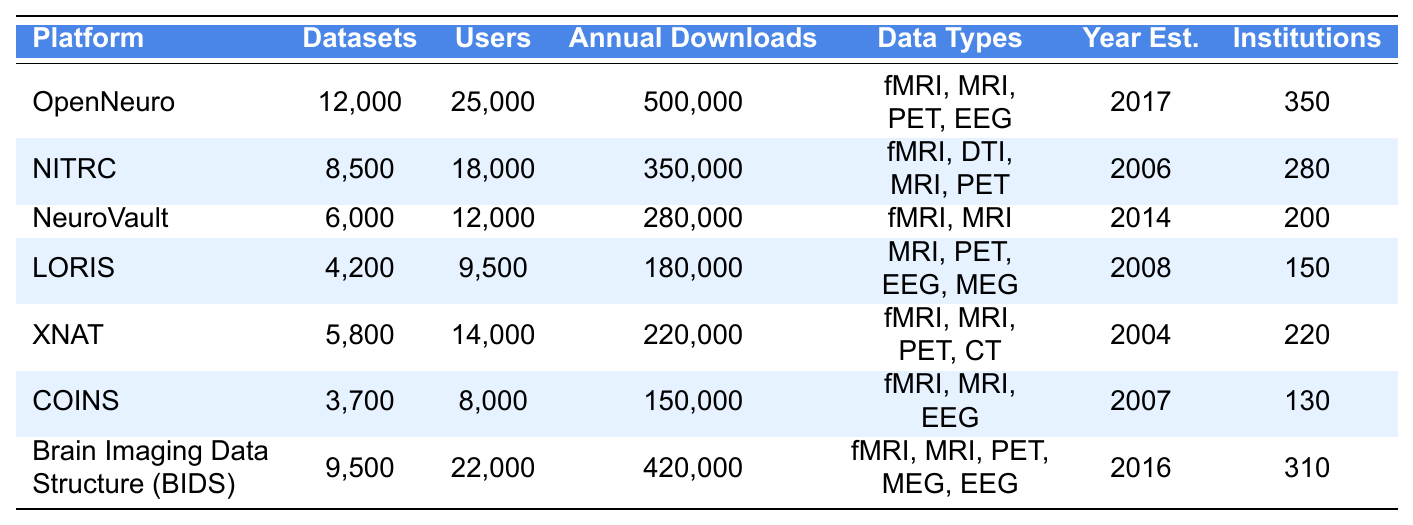What is the total number of datasets available across all platforms? To find the total number of datasets, we sum all the values in the datasets column: 12000 + 8500 + 6000 + 4200 + 5800 + 3700 + 9500 = 40800.
Answer: 40800 Which platform has the highest number of registered users? By inspecting the users column, OpenNeuro has the highest number of registered users with 25000.
Answer: OpenNeuro What percentage of institutions use the NITRC platform compared to OpenNeuro? To find the percentage, first determine the number of institutions using NITRC (280) and OpenNeuro (350). Then calculate: (280 / 350) * 100 = 80%.
Answer: 80% Is the statement "NITRC was established before Brain Imaging Data Structure (BIDS)" true? NITRC was established in 2006 and BIDS in 2016, so the statement is true as 2006 is earlier than 2016.
Answer: True Which platform has the lowest annual downloads, and what is that number? By comparing the annual downloads, COINS has the lowest with 150000 downloads.
Answer: COINS, 150000 If we look for the median number of datasets across these platforms, what do we find? Arranging the number of datasets (from least to most): 3700, 4200, 5800, 6000, 8500, 12000. The median of these six values, which is the average of the third and fourth values, is (5800 + 6000) / 2 = 5900.
Answer: 5900 What is the average number of registered users for all the platforms? To calculate the average, sum the registered users: 25000 + 18000 + 12000 + 9500 + 14000 + 8000 + 22000 = 108500, then divide by the number of platforms (7): 108500 / 7 = 15500.
Answer: 15500 Identify the platform that supports both EEG and fMRI data types. The platforms supporting both EEG and fMRI are OpenNeuro, LORIS, COINS, and Brain Imaging Data Structure (BIDS). The inquiry looks for any one of them, and OpenNeuro fits the criteria.
Answer: OpenNeuro How many more datasets does XNAT have than LORIS? XNAT has 5800 datasets and LORIS has 4200. To find the difference: 5800 - 4200 = 1600.
Answer: 1600 What is the total of annual downloads for the platforms established in 2007 or later? The platforms established in 2007 or later are OpenNeuro (2017), Brain Imaging Data Structure (BIDS, 2016), and COINS (2007). Adding their annual downloads yields: 500000 + 420000 + 150000 = 1070000.
Answer: 1070000 